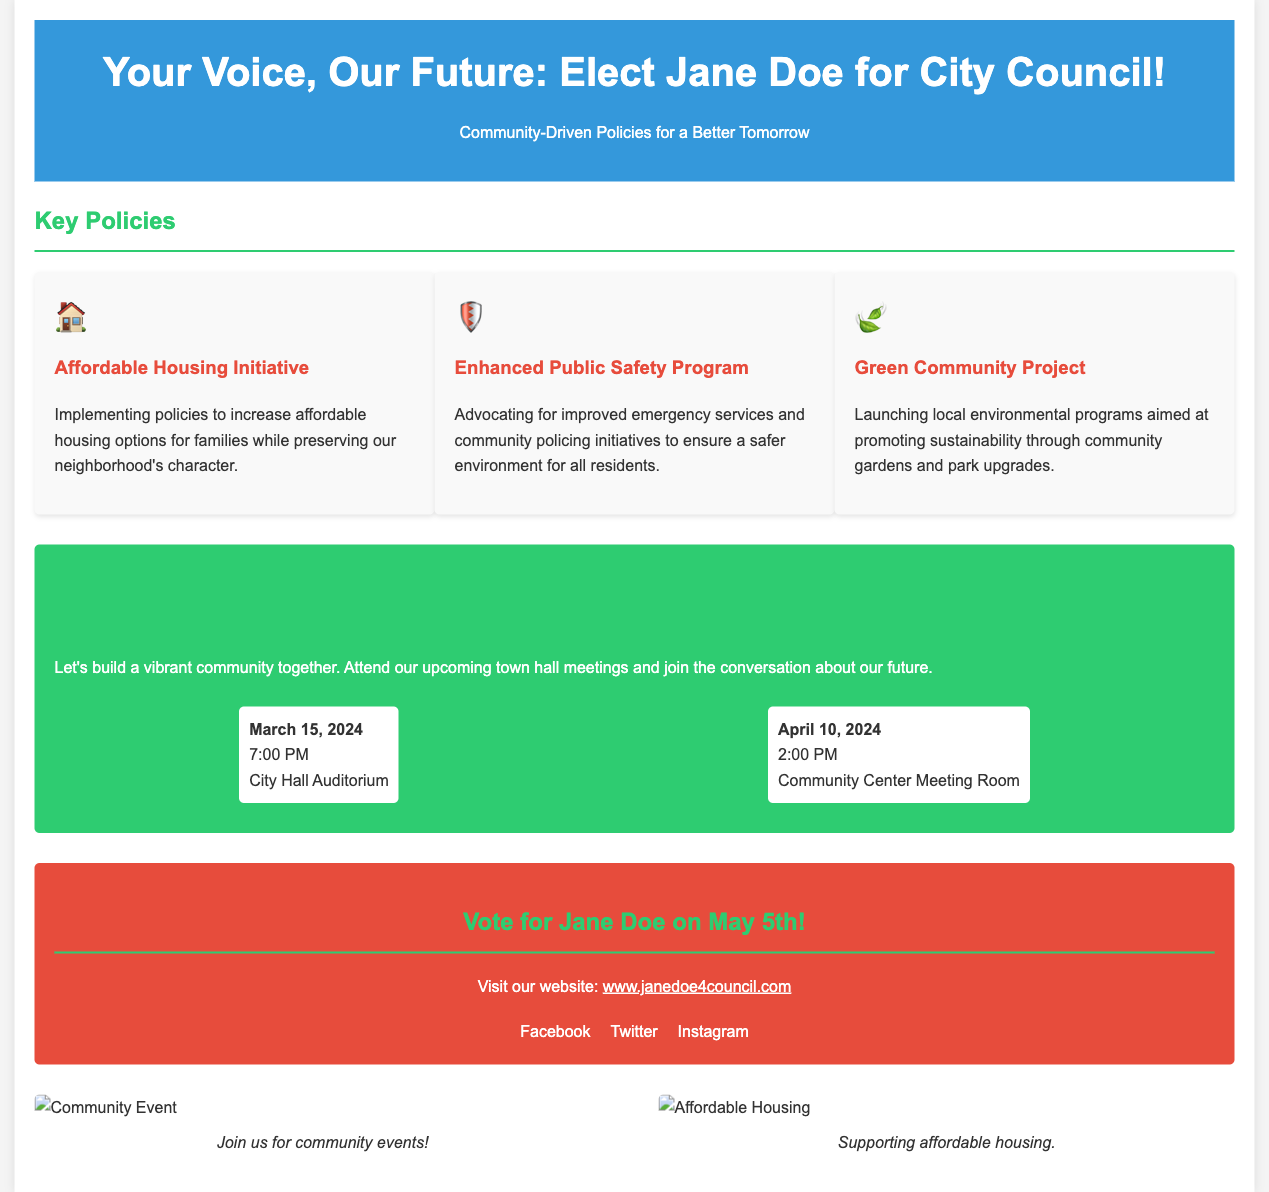What is the candidate's name? The candidate's name is prominently mentioned in the header as Jane Doe.
Answer: Jane Doe What is the date of the first town hall meeting? The first town hall meeting is scheduled for March 15, 2024.
Answer: March 15, 2024 What is one of the key policies listed? The document lists three key policies, including the Affordable Housing Initiative.
Answer: Affordable Housing Initiative What time does the second town hall meeting start? The second town hall meeting is set for 2:00 PM on April 10, 2024.
Answer: 2:00 PM What color is the background of the engagement section? The engagement section has a green background color, which is specified in the styling.
Answer: Green How many social media platforms are mentioned? The document mentions three social media platforms for engagement: Facebook, Twitter, and Instagram.
Answer: Three What is the call to action in the document? The call to action encourages voters to vote for Jane Doe on May 5th.
Answer: Vote for Jane Doe on May 5th What type of program is being advocated for under public safety? The document mentions advocating for improved emergency services and community policing initiatives.
Answer: Improved emergency services and community policing initiatives What initiative focuses on environmental programs? The Green Community Project is the initiative that focuses on environmental sustainability.
Answer: Green Community Project 